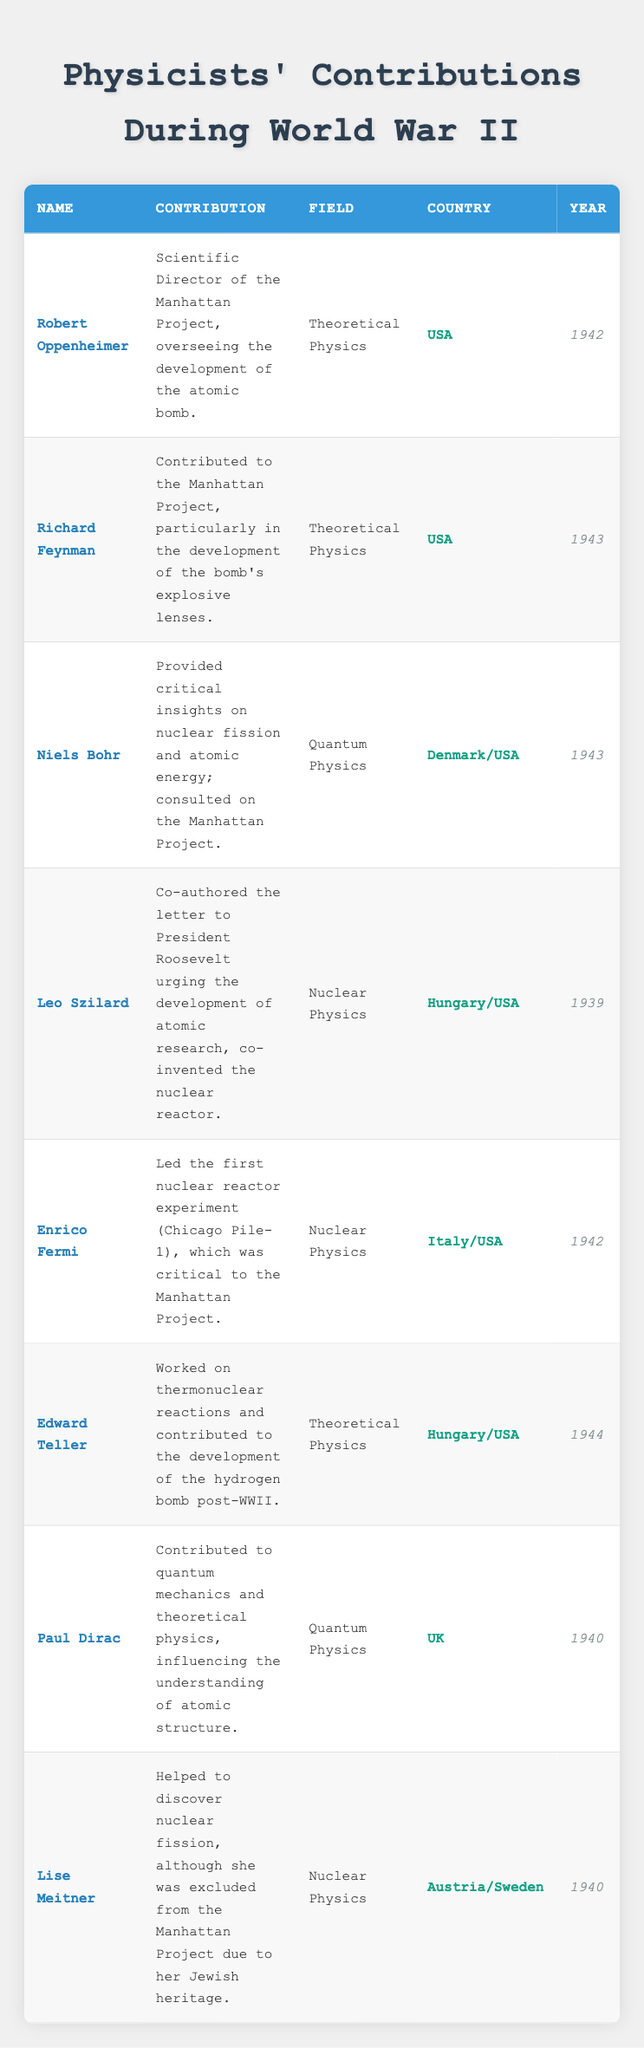What was Robert Oppenheimer's main contribution during World War II? According to the table, Robert Oppenheimer served as the Scientific Director of the Manhattan Project, where he oversaw the development of the atomic bomb.
Answer: He was the Scientific Director of the Manhattan Project Which country did Niels Bohr represent? The table lists Niels Bohr as having connections to both Denmark and the USA, indicating he represented both countries during his contributions.
Answer: He represented Denmark/USA How many physicists contributed to the Manhattan Project according to the table? By examining the table, the physicists who contributed to the Manhattan Project include Robert Oppenheimer, Richard Feynman, Niels Bohr, and Enrico Fermi, totaling four individuals.
Answer: Four physicists Was Lise Meitner included in the Manhattan Project? The table states that Lise Meitner helped discover nuclear fission but was excluded from the Manhattan Project due to her Jewish heritage, making the answer "no."
Answer: No What year did Leo Szilard co-author the letter to President Roosevelt? The table indicates that Leo Szilard co-authored the letter in 1939, which is directly listed under the Year column next to his name.
Answer: 1939 Which physicist worked on thermonuclear reactions during World War II, and in which year did this occur? The table lists Edward Teller as the physicist who worked on thermonuclear reactions, contributing to the hydrogen bomb post-World War II. However, he specifically worked during 1944, according to the Year column.
Answer: Edward Teller, 1944 Find the physicist with contributions related to quantum mechanics and their year of contribution. Paul Dirac is listed in the table as having contributed to quantum mechanics. The table specifies that his contributions occurred in 1940, which can be found in the Year column next to his name.
Answer: Paul Dirac, 1940 How did the contributions of Leo Szilard influence nuclear physics? The table mentions that Leo Szilard co-authored a letter urging the development of atomic research and co-invented the nuclear reactor, indicating his significant influence on nuclear physics during its formative years.
Answer: He co-authored a letter urging atomic research and co-invented the nuclear reactor 